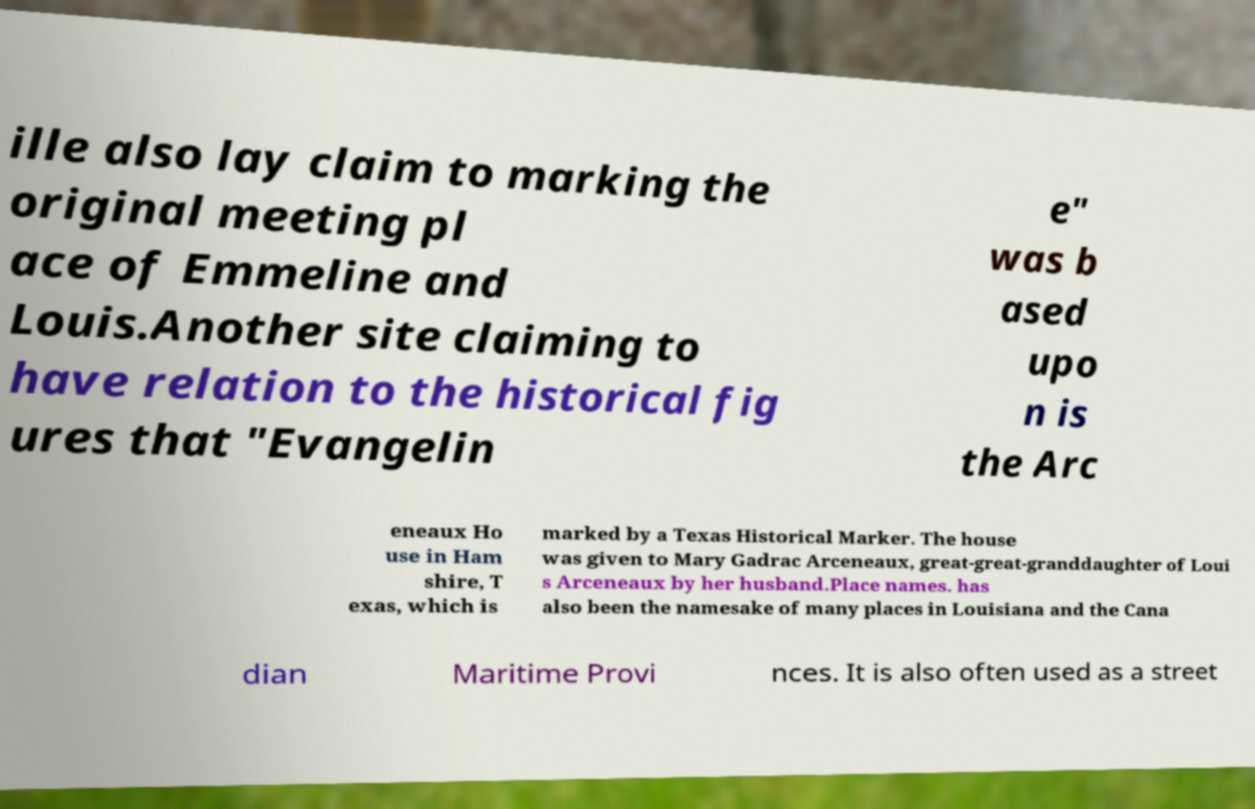Please read and relay the text visible in this image. What does it say? ille also lay claim to marking the original meeting pl ace of Emmeline and Louis.Another site claiming to have relation to the historical fig ures that "Evangelin e" was b ased upo n is the Arc eneaux Ho use in Ham shire, T exas, which is marked by a Texas Historical Marker. The house was given to Mary Gadrac Arceneaux, great-great-granddaughter of Loui s Arceneaux by her husband.Place names. has also been the namesake of many places in Louisiana and the Cana dian Maritime Provi nces. It is also often used as a street 